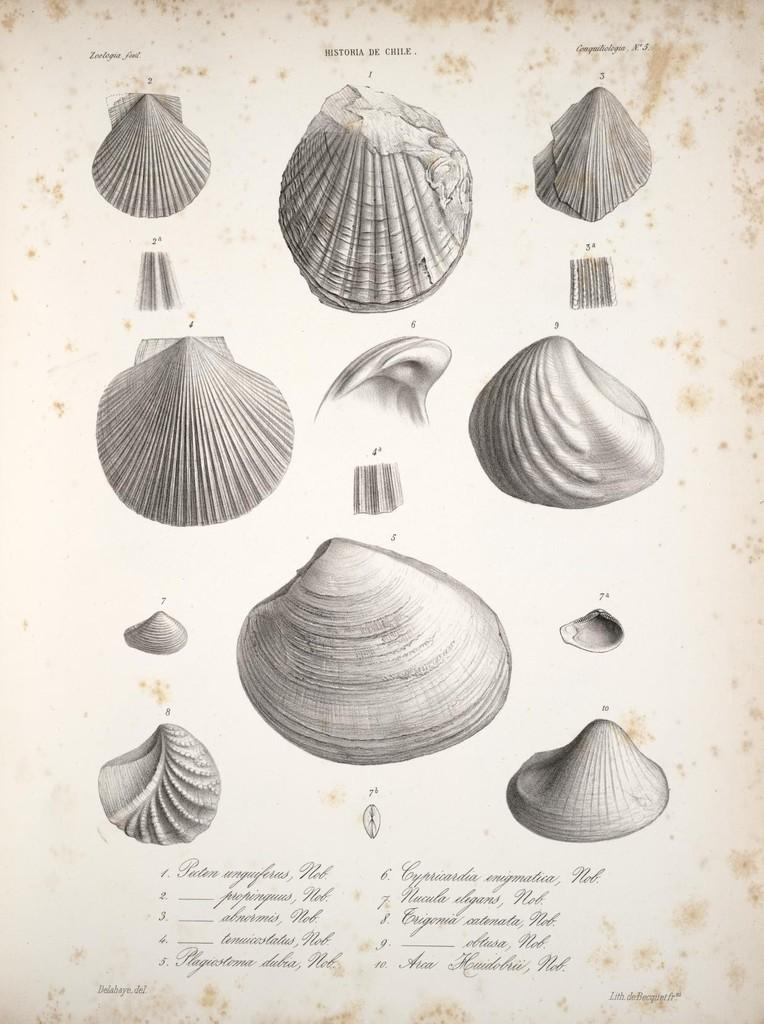What is the main subject of the image? The main subject of the image is a page. What is depicted on the page? The page contains types of shells. Is there any text present on the page? Yes, there is text on the page. What is the sun doing in the image? There is no sun present in the image; it features a page with shells and text. How many times does the person run across the page in the image? There is no person running across the page in the image. 